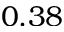Convert formula to latex. <formula><loc_0><loc_0><loc_500><loc_500>0 . 3 8</formula> 